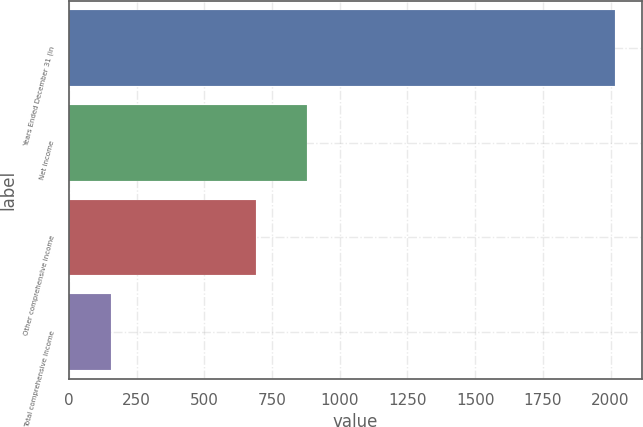Convert chart. <chart><loc_0><loc_0><loc_500><loc_500><bar_chart><fcel>Years Ended December 31 (in<fcel>Net income<fcel>Other comprehensive income<fcel>Total comprehensive income<nl><fcel>2016<fcel>879<fcel>693<fcel>156<nl></chart> 